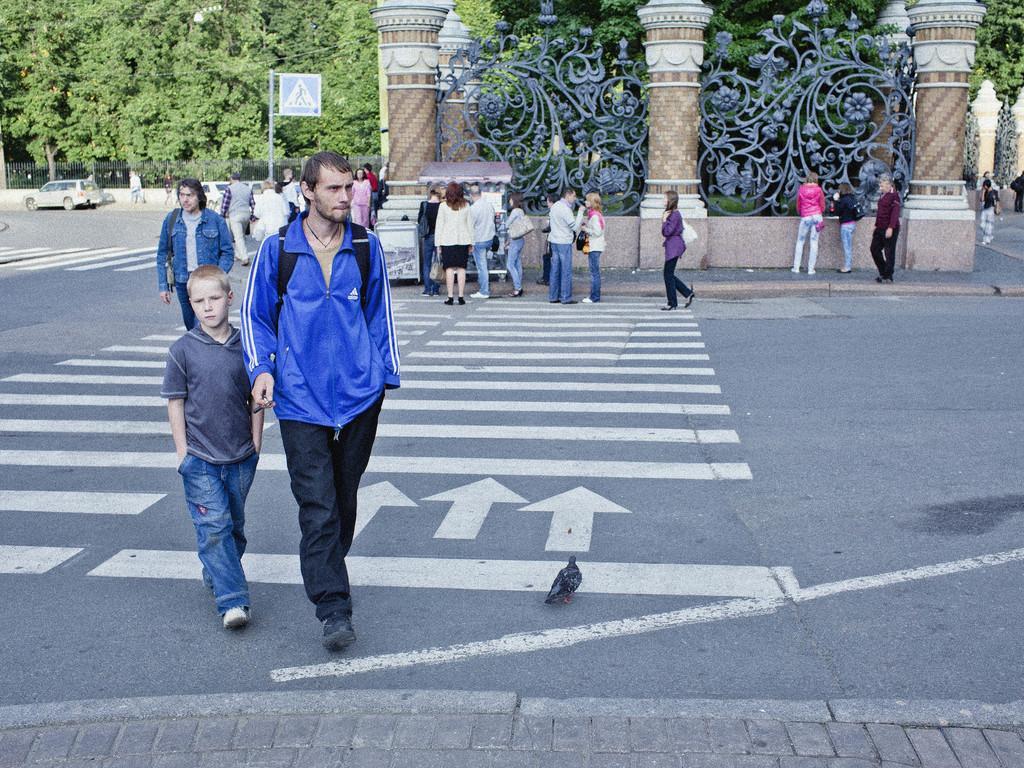How would you summarize this image in a sentence or two? In this image we can see people walking on the road, trees, motor vehicle on the road, fences and cables. 